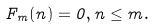Convert formula to latex. <formula><loc_0><loc_0><loc_500><loc_500>F _ { m } ( n ) = 0 , n \leq m .</formula> 